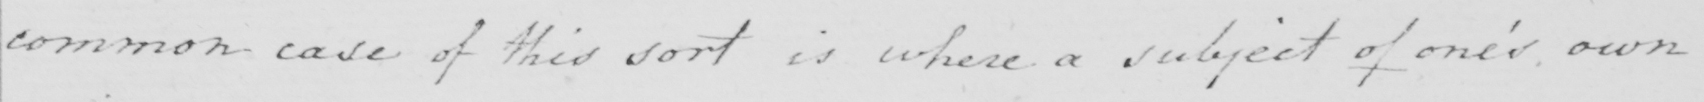Transcribe the text shown in this historical manuscript line. common case of this sort is where a subject of one ' s own 